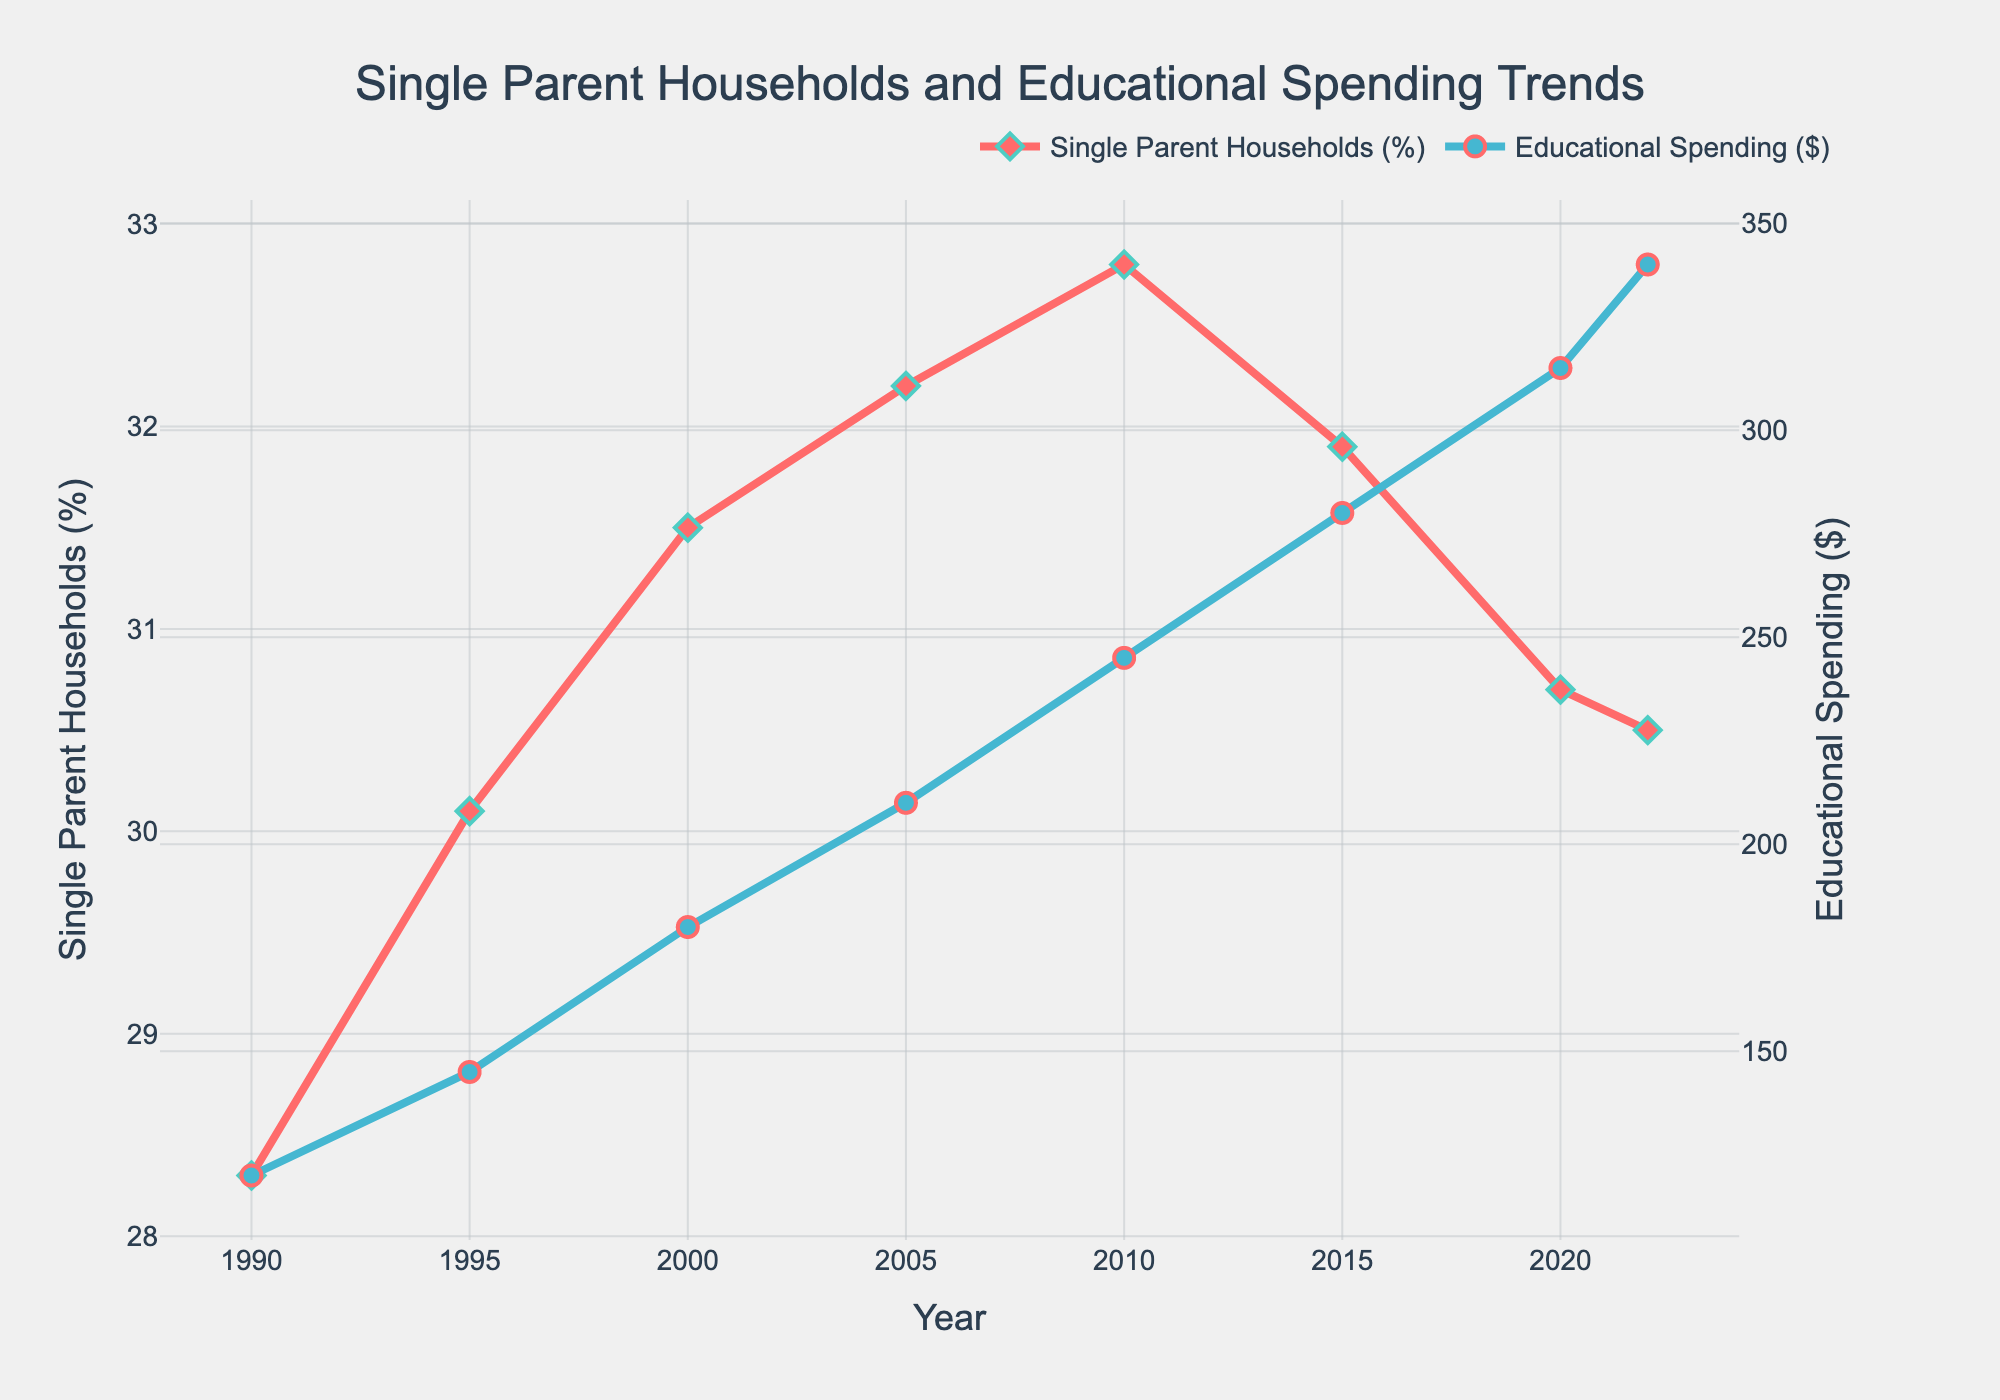What year had the highest percentage of single-parent households? The highest percentage of single-parent households can be found by looking at the peak value on the red line in the plot, which occurs in 2010.
Answer: 2010 By how much did educational spending increase from 1990 to 2022? The educational spending in 1990 was $120, and in 2022 it was $340. The increase is calculated as $340 - $120 = $220.
Answer: $220 Which year saw the largest difference between single-parent households and educational spending? To find this, we need to look at the year with the most significant visual gap between the red line (single-parent households) and the blue line (educational spending). The largest difference appears in 2010.
Answer: 2010 What was the trend in single-parent households between 2000 and 2015? From 2000 to 2015, the percentage of single-parent households initially increased from 31.5% to 32.8% in 2010 and then decreased to 31.9% in 2015.
Answer: Increased then decreased What is the average percentage of single-parent households from 1990 to 2022? We sum up all the percentages from 1990 to 2022 and divide by the number of years: (28.3 + 30.1 + 31.5 + 32.2 + 32.8 + 31.9 + 30.7 + 30.5) / 8 = 31.0%.
Answer: 31.0% Which has a steeper incline, the increase in single-parent households from 1990 to 2000 or the increase in educational spending over the same period? To determine the steeper incline, we compare the slopes. Increase in single-parent households is 31.5% - 28.3% = 3.2% over 10 years. Increase in educational spending is $180 - $120 = $60 over 10 years. The incline for educational spending appears visually steeper.
Answer: Educational spending How did the percentage of single-parent households change from 2015 to 2022? The percentage of single-parent households decreased from 31.9% in 2015 to 30.5% in 2022, indicating a decrease of 1.4%.
Answer: Decreased by 1.4% Compare the percentage change in single-parent households and educational spending between 2010 and 2020. Single-parent households changed from 32.8% to 30.7%, a decrease of 2.1%. Educational spending changed from $245 to $315, an increase of $70.
Answer: Households decreased, spending increased What is the overall trend in educational spending from 1990 to 2022? The blue line shows a consistent upward trend, indicating that educational spending has increased steadily from $120 in 1990 to $340 in 2022.
Answer: Increasing trend How does the rate of change in educational spending compare to the rate of change in single-parent households between 1990 and 2022? Educational spending increased significantly from $120 to $340, while the percentage of single-parent households increased from 28.3% to 30.5%. The rate of change in educational spending is much higher.
Answer: Spending rate higher 